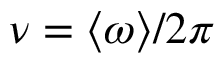Convert formula to latex. <formula><loc_0><loc_0><loc_500><loc_500>\nu = \langle \omega \rangle / 2 \pi</formula> 